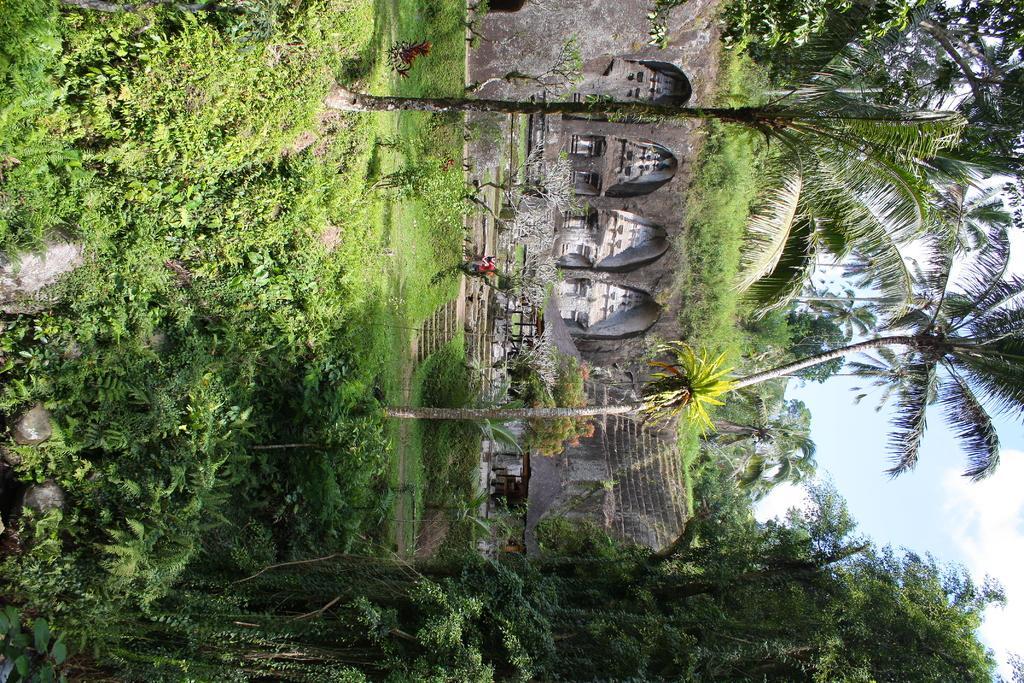Describe this image in one or two sentences. In this picture I can observe some plants and grass on the ground. In the middle of the picture I can observe a wall. In the background there are trees and sky. 